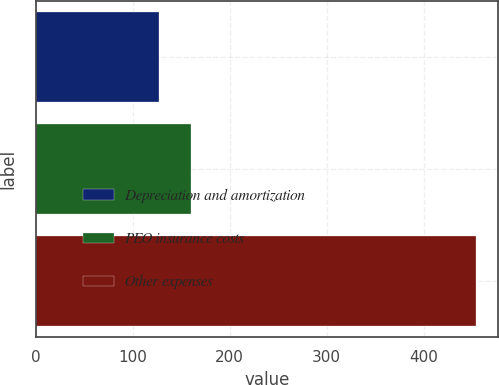<chart> <loc_0><loc_0><loc_500><loc_500><bar_chart><fcel>Depreciation and amortization<fcel>PEO insurance costs<fcel>Other expenses<nl><fcel>126.9<fcel>159.62<fcel>454.1<nl></chart> 